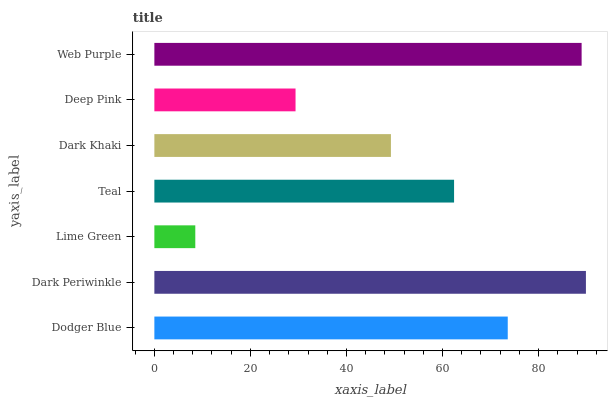Is Lime Green the minimum?
Answer yes or no. Yes. Is Dark Periwinkle the maximum?
Answer yes or no. Yes. Is Dark Periwinkle the minimum?
Answer yes or no. No. Is Lime Green the maximum?
Answer yes or no. No. Is Dark Periwinkle greater than Lime Green?
Answer yes or no. Yes. Is Lime Green less than Dark Periwinkle?
Answer yes or no. Yes. Is Lime Green greater than Dark Periwinkle?
Answer yes or no. No. Is Dark Periwinkle less than Lime Green?
Answer yes or no. No. Is Teal the high median?
Answer yes or no. Yes. Is Teal the low median?
Answer yes or no. Yes. Is Dodger Blue the high median?
Answer yes or no. No. Is Web Purple the low median?
Answer yes or no. No. 